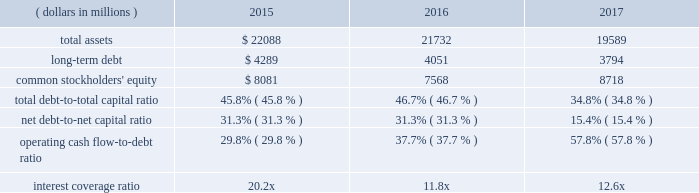Operating cash flow from continuing operations for 2017 was $ 2.7 billion , a $ 191 million , or 8 percent increase compared with 2016 , reflecting higher earnings and favorable changes in working capital .
Operating cash flow from continuing operations of $ 2.5 billion in 2016 was a 23 percent increase compared to $ 2.0 billion in 2015 , as comparisons benefited from income taxes of $ 424 million paid on the gains from divestitures in 2015 .
At september 30 , 2017 , operating working capital as a percent of sales increased to 6.6 percent due to higher levels of working capital in the acquired valves & controls business , compared with 5.2 percent and 7.2 percent in 2016 and 2015 , respectively .
Operating cash flow from continuing operations funded capital expenditures of $ 476 million , dividends of $ 1239 million , common stock purchases of $ 400 million , and was also used to partially pay down debt in 2017 .
Proceeds of $ 5.1 billion from the sales of the network power systems and power generation , motors and drives businesses funded acquisitions of $ 2990 million , cash used for discontinued operations of $ 778 million and repayments of short-term borrowings and long-term debt of approximately $ 1.3 billion .
Contributions to pension plans were $ 45 million in 2017 , $ 66 million in 2016 and $ 53 million in 2015 .
Capital expenditures related to continuing operations were $ 476 million , $ 447 million and $ 588 million in 2017 , 2016 and 2015 , respectively .
Free cash flow from continuing operations ( operating cash flow less capital expenditures ) was $ 2.2 billion in 2017 , up 8 percent .
Free cash flow was $ 2.1 billion in 2016 , compared with $ 1.5 billion in 2015 .
The company is targeting capital spending of approximately $ 550 million in 2018 .
Net cash paid in connection with acquisitions was $ 2990 million , $ 132 million and $ 324 million in 2017 , 2016 and 2015 , respectively .
Proceeds from divestitures not classified as discontinued operations were $ 39 million in 2017 and $ 1812 million in 2015 .
Dividends were $ 1239 million ( $ 1.92 per share ) in 2017 , compared with $ 1227 million ( $ 1.90 per share ) in 2016 and $ 1269 million ( $ 1.88 per share ) in 2015 .
In november 2017 , the board of directors voted to increase the quarterly cash dividend 1 percent , to an annualized rate of $ 1.94 per share .
Purchases of emerson common stock totaled $ 400 million , $ 601 million and $ 2487 million in 2017 , 2016 and 2015 , respectively , at average per share prices of $ 60.51 , $ 48.11 and $ 57.68 .
The board of directors authorized the purchase of up to 70 million common shares in november 2015 , and 56.9 million shares remain available for purchase under this authorization .
The company purchased 6.6 million shares in 2017 under the november 2015 authorization .
In 2016 , the company purchased 12.5 million shares under a combination of the november 2015 authorization and the remainder of the may 2013 authorization .
A total of 43.1 million shares were purchased in 2015 under the may 2013 authorization .
Leverage/capitalization ( dollars in millions ) 2015 2016 2017 .
Total debt , which includes long-term debt , current maturities of long-term debt , commercial paper and other short-term borrowings , was $ 4.7 billion , $ 6.6 billion and $ 6.8 billion for 2017 , 2016 and 2015 , respectively .
During the year , the company repaid $ 250 million of 5.125% ( 5.125 % ) notes that matured in december 2016 .
In 2015 , the company issued $ 500 million of 2.625% ( 2.625 % ) notes due december 2021 and $ 500 million of 3.150% ( 3.150 % ) notes due june 2025 , and repaid $ 250 million of 5.0% ( 5.0 % ) notes that matured in december 2014 and $ 250 million of 4.125% ( 4.125 % ) notes that matured in april 2015 .
The total debt-to-capital ratio and the net debt-to-net capital ratio ( less cash and short-term investments ) decreased in 2017 due to lower total debt outstanding and higher common stockholders 2019 equity from changes in other comprehensive income .
The total debt-to-capital ratio and the net debt-to-net capital ratio ( less cash and short-term investments ) increased in 2016 due to lower common stockholders 2019 equity from share repurchases and changes in other comprehensive income .
The operating cash flow from continuing operations-to-debt ratio increased in 2017 primarily due to lower debt in the current year .
The operating cash flow from continuing operations-to- debt ratio increased in 2016 primarily due to taxes paid in 2015 on the divestiture gains and lower debt in 2016 .
The interest coverage ratio is computed as earnings from continuing operations before income taxes plus interest expense , divided by interest expense .
The increase in interest coverage in 2017 reflects lower interest expense in the current year .
The decrease in interest coverage in 2016 reflects lower pretax earnings , largely due to the divestiture gains of $ 1039 million in 2015 , and slightly higher interest expense .
In april 2014 , the company entered into a $ 3.5 billion five- year revolving backup credit facility with various banks , which replaced the december 2010 $ 2.75 billion facility .
The credit facility is maintained to support general corporate purposes , including commercial paper borrowing .
The company has not incurred any borrowings under this or previous facilities .
The credit facility contains no financial covenants and is not subject to termination based on a change of credit rating or material adverse changes .
The facility is unsecured and may be accessed under various interest rate and currency denomination alternatives at the company 2019s option .
Fees to maintain the facility are immaterial .
The company also maintains a universal shelf registration statement on file with the sec under which .
What percentage of total debt was long-term debt in 2016? 
Computations: (4051 / (6.6 * 1000))
Answer: 0.61379. 